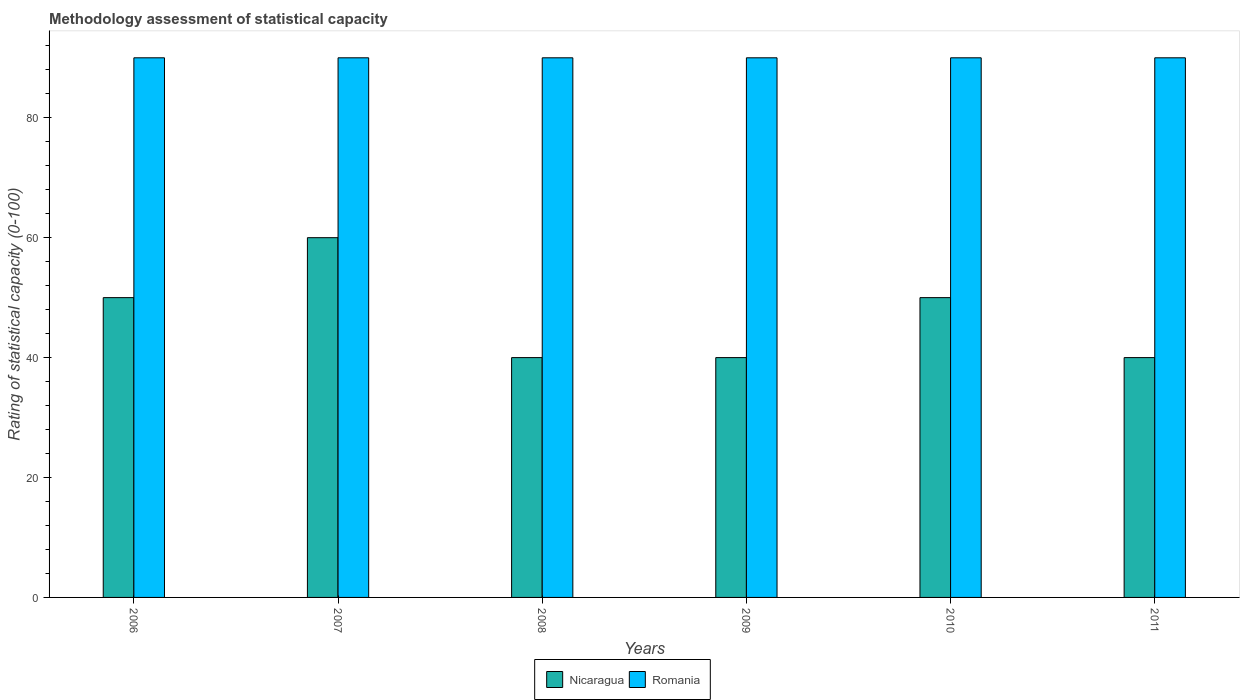How many different coloured bars are there?
Give a very brief answer. 2. Are the number of bars on each tick of the X-axis equal?
Offer a terse response. Yes. How many bars are there on the 1st tick from the left?
Ensure brevity in your answer.  2. How many bars are there on the 4th tick from the right?
Offer a very short reply. 2. In how many cases, is the number of bars for a given year not equal to the number of legend labels?
Ensure brevity in your answer.  0. What is the rating of statistical capacity in Romania in 2010?
Give a very brief answer. 90. Across all years, what is the maximum rating of statistical capacity in Romania?
Ensure brevity in your answer.  90. Across all years, what is the minimum rating of statistical capacity in Nicaragua?
Keep it short and to the point. 40. In which year was the rating of statistical capacity in Romania minimum?
Provide a succinct answer. 2006. What is the total rating of statistical capacity in Nicaragua in the graph?
Provide a succinct answer. 280. What is the difference between the rating of statistical capacity in Nicaragua in 2008 and the rating of statistical capacity in Romania in 2006?
Offer a terse response. -50. What is the average rating of statistical capacity in Nicaragua per year?
Provide a short and direct response. 46.67. In the year 2010, what is the difference between the rating of statistical capacity in Romania and rating of statistical capacity in Nicaragua?
Ensure brevity in your answer.  40. Is the difference between the rating of statistical capacity in Romania in 2008 and 2009 greater than the difference between the rating of statistical capacity in Nicaragua in 2008 and 2009?
Your response must be concise. No. What is the difference between the highest and the second highest rating of statistical capacity in Romania?
Make the answer very short. 0. What is the difference between the highest and the lowest rating of statistical capacity in Romania?
Your answer should be compact. 0. In how many years, is the rating of statistical capacity in Nicaragua greater than the average rating of statistical capacity in Nicaragua taken over all years?
Provide a short and direct response. 3. What does the 1st bar from the left in 2008 represents?
Your response must be concise. Nicaragua. What does the 2nd bar from the right in 2007 represents?
Your answer should be very brief. Nicaragua. How many bars are there?
Your answer should be compact. 12. Does the graph contain grids?
Your response must be concise. No. Where does the legend appear in the graph?
Keep it short and to the point. Bottom center. What is the title of the graph?
Ensure brevity in your answer.  Methodology assessment of statistical capacity. Does "Mozambique" appear as one of the legend labels in the graph?
Provide a short and direct response. No. What is the label or title of the X-axis?
Your answer should be very brief. Years. What is the label or title of the Y-axis?
Provide a short and direct response. Rating of statistical capacity (0-100). What is the Rating of statistical capacity (0-100) of Nicaragua in 2007?
Give a very brief answer. 60. What is the Rating of statistical capacity (0-100) of Nicaragua in 2009?
Your answer should be very brief. 40. What is the Rating of statistical capacity (0-100) in Romania in 2010?
Ensure brevity in your answer.  90. What is the Rating of statistical capacity (0-100) of Nicaragua in 2011?
Offer a terse response. 40. Across all years, what is the maximum Rating of statistical capacity (0-100) in Nicaragua?
Offer a very short reply. 60. Across all years, what is the minimum Rating of statistical capacity (0-100) in Nicaragua?
Keep it short and to the point. 40. What is the total Rating of statistical capacity (0-100) of Nicaragua in the graph?
Offer a very short reply. 280. What is the total Rating of statistical capacity (0-100) in Romania in the graph?
Your answer should be very brief. 540. What is the difference between the Rating of statistical capacity (0-100) in Romania in 2006 and that in 2007?
Give a very brief answer. 0. What is the difference between the Rating of statistical capacity (0-100) in Nicaragua in 2006 and that in 2009?
Your answer should be compact. 10. What is the difference between the Rating of statistical capacity (0-100) in Romania in 2006 and that in 2009?
Your answer should be very brief. 0. What is the difference between the Rating of statistical capacity (0-100) in Nicaragua in 2006 and that in 2010?
Your answer should be very brief. 0. What is the difference between the Rating of statistical capacity (0-100) of Romania in 2006 and that in 2010?
Your answer should be very brief. 0. What is the difference between the Rating of statistical capacity (0-100) of Nicaragua in 2006 and that in 2011?
Give a very brief answer. 10. What is the difference between the Rating of statistical capacity (0-100) in Nicaragua in 2007 and that in 2008?
Make the answer very short. 20. What is the difference between the Rating of statistical capacity (0-100) in Romania in 2007 and that in 2008?
Keep it short and to the point. 0. What is the difference between the Rating of statistical capacity (0-100) of Nicaragua in 2007 and that in 2010?
Keep it short and to the point. 10. What is the difference between the Rating of statistical capacity (0-100) of Romania in 2008 and that in 2009?
Give a very brief answer. 0. What is the difference between the Rating of statistical capacity (0-100) of Nicaragua in 2008 and that in 2010?
Give a very brief answer. -10. What is the difference between the Rating of statistical capacity (0-100) in Nicaragua in 2008 and that in 2011?
Your answer should be very brief. 0. What is the difference between the Rating of statistical capacity (0-100) in Romania in 2008 and that in 2011?
Provide a short and direct response. 0. What is the difference between the Rating of statistical capacity (0-100) in Nicaragua in 2009 and that in 2010?
Ensure brevity in your answer.  -10. What is the difference between the Rating of statistical capacity (0-100) in Romania in 2009 and that in 2010?
Offer a very short reply. 0. What is the difference between the Rating of statistical capacity (0-100) in Nicaragua in 2009 and that in 2011?
Offer a terse response. 0. What is the difference between the Rating of statistical capacity (0-100) in Romania in 2009 and that in 2011?
Provide a succinct answer. 0. What is the difference between the Rating of statistical capacity (0-100) of Nicaragua in 2010 and that in 2011?
Ensure brevity in your answer.  10. What is the difference between the Rating of statistical capacity (0-100) of Nicaragua in 2006 and the Rating of statistical capacity (0-100) of Romania in 2007?
Your answer should be very brief. -40. What is the difference between the Rating of statistical capacity (0-100) of Nicaragua in 2006 and the Rating of statistical capacity (0-100) of Romania in 2009?
Provide a succinct answer. -40. What is the difference between the Rating of statistical capacity (0-100) of Nicaragua in 2006 and the Rating of statistical capacity (0-100) of Romania in 2011?
Give a very brief answer. -40. What is the difference between the Rating of statistical capacity (0-100) of Nicaragua in 2008 and the Rating of statistical capacity (0-100) of Romania in 2010?
Make the answer very short. -50. What is the difference between the Rating of statistical capacity (0-100) in Nicaragua in 2008 and the Rating of statistical capacity (0-100) in Romania in 2011?
Keep it short and to the point. -50. What is the difference between the Rating of statistical capacity (0-100) of Nicaragua in 2010 and the Rating of statistical capacity (0-100) of Romania in 2011?
Your answer should be compact. -40. What is the average Rating of statistical capacity (0-100) in Nicaragua per year?
Offer a very short reply. 46.67. What is the average Rating of statistical capacity (0-100) of Romania per year?
Make the answer very short. 90. In the year 2006, what is the difference between the Rating of statistical capacity (0-100) in Nicaragua and Rating of statistical capacity (0-100) in Romania?
Make the answer very short. -40. In the year 2007, what is the difference between the Rating of statistical capacity (0-100) of Nicaragua and Rating of statistical capacity (0-100) of Romania?
Offer a terse response. -30. In the year 2008, what is the difference between the Rating of statistical capacity (0-100) of Nicaragua and Rating of statistical capacity (0-100) of Romania?
Your response must be concise. -50. In the year 2009, what is the difference between the Rating of statistical capacity (0-100) of Nicaragua and Rating of statistical capacity (0-100) of Romania?
Ensure brevity in your answer.  -50. What is the ratio of the Rating of statistical capacity (0-100) of Nicaragua in 2006 to that in 2007?
Your answer should be compact. 0.83. What is the ratio of the Rating of statistical capacity (0-100) in Romania in 2006 to that in 2007?
Give a very brief answer. 1. What is the ratio of the Rating of statistical capacity (0-100) in Nicaragua in 2006 to that in 2008?
Your answer should be compact. 1.25. What is the ratio of the Rating of statistical capacity (0-100) in Romania in 2006 to that in 2009?
Keep it short and to the point. 1. What is the ratio of the Rating of statistical capacity (0-100) in Nicaragua in 2006 to that in 2010?
Your response must be concise. 1. What is the ratio of the Rating of statistical capacity (0-100) of Nicaragua in 2007 to that in 2008?
Give a very brief answer. 1.5. What is the ratio of the Rating of statistical capacity (0-100) of Romania in 2007 to that in 2008?
Offer a very short reply. 1. What is the ratio of the Rating of statistical capacity (0-100) of Romania in 2007 to that in 2009?
Provide a short and direct response. 1. What is the ratio of the Rating of statistical capacity (0-100) of Romania in 2007 to that in 2010?
Ensure brevity in your answer.  1. What is the ratio of the Rating of statistical capacity (0-100) of Nicaragua in 2007 to that in 2011?
Provide a succinct answer. 1.5. What is the ratio of the Rating of statistical capacity (0-100) of Romania in 2007 to that in 2011?
Give a very brief answer. 1. What is the ratio of the Rating of statistical capacity (0-100) of Romania in 2008 to that in 2011?
Keep it short and to the point. 1. What is the ratio of the Rating of statistical capacity (0-100) in Nicaragua in 2009 to that in 2010?
Offer a terse response. 0.8. What is the difference between the highest and the second highest Rating of statistical capacity (0-100) of Nicaragua?
Give a very brief answer. 10. What is the difference between the highest and the second highest Rating of statistical capacity (0-100) in Romania?
Provide a short and direct response. 0. 